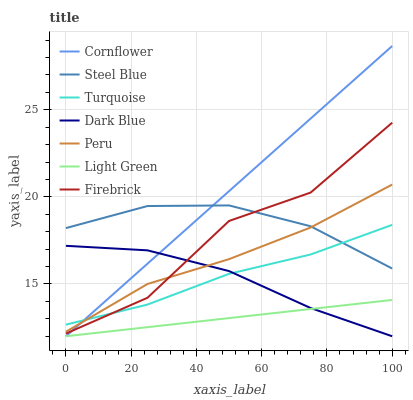Does Light Green have the minimum area under the curve?
Answer yes or no. Yes. Does Cornflower have the maximum area under the curve?
Answer yes or no. Yes. Does Turquoise have the minimum area under the curve?
Answer yes or no. No. Does Turquoise have the maximum area under the curve?
Answer yes or no. No. Is Light Green the smoothest?
Answer yes or no. Yes. Is Firebrick the roughest?
Answer yes or no. Yes. Is Turquoise the smoothest?
Answer yes or no. No. Is Turquoise the roughest?
Answer yes or no. No. Does Turquoise have the lowest value?
Answer yes or no. No. Does Cornflower have the highest value?
Answer yes or no. Yes. Does Turquoise have the highest value?
Answer yes or no. No. Is Light Green less than Firebrick?
Answer yes or no. Yes. Is Steel Blue greater than Light Green?
Answer yes or no. Yes. Does Firebrick intersect Cornflower?
Answer yes or no. Yes. Is Firebrick less than Cornflower?
Answer yes or no. No. Is Firebrick greater than Cornflower?
Answer yes or no. No. Does Light Green intersect Firebrick?
Answer yes or no. No. 